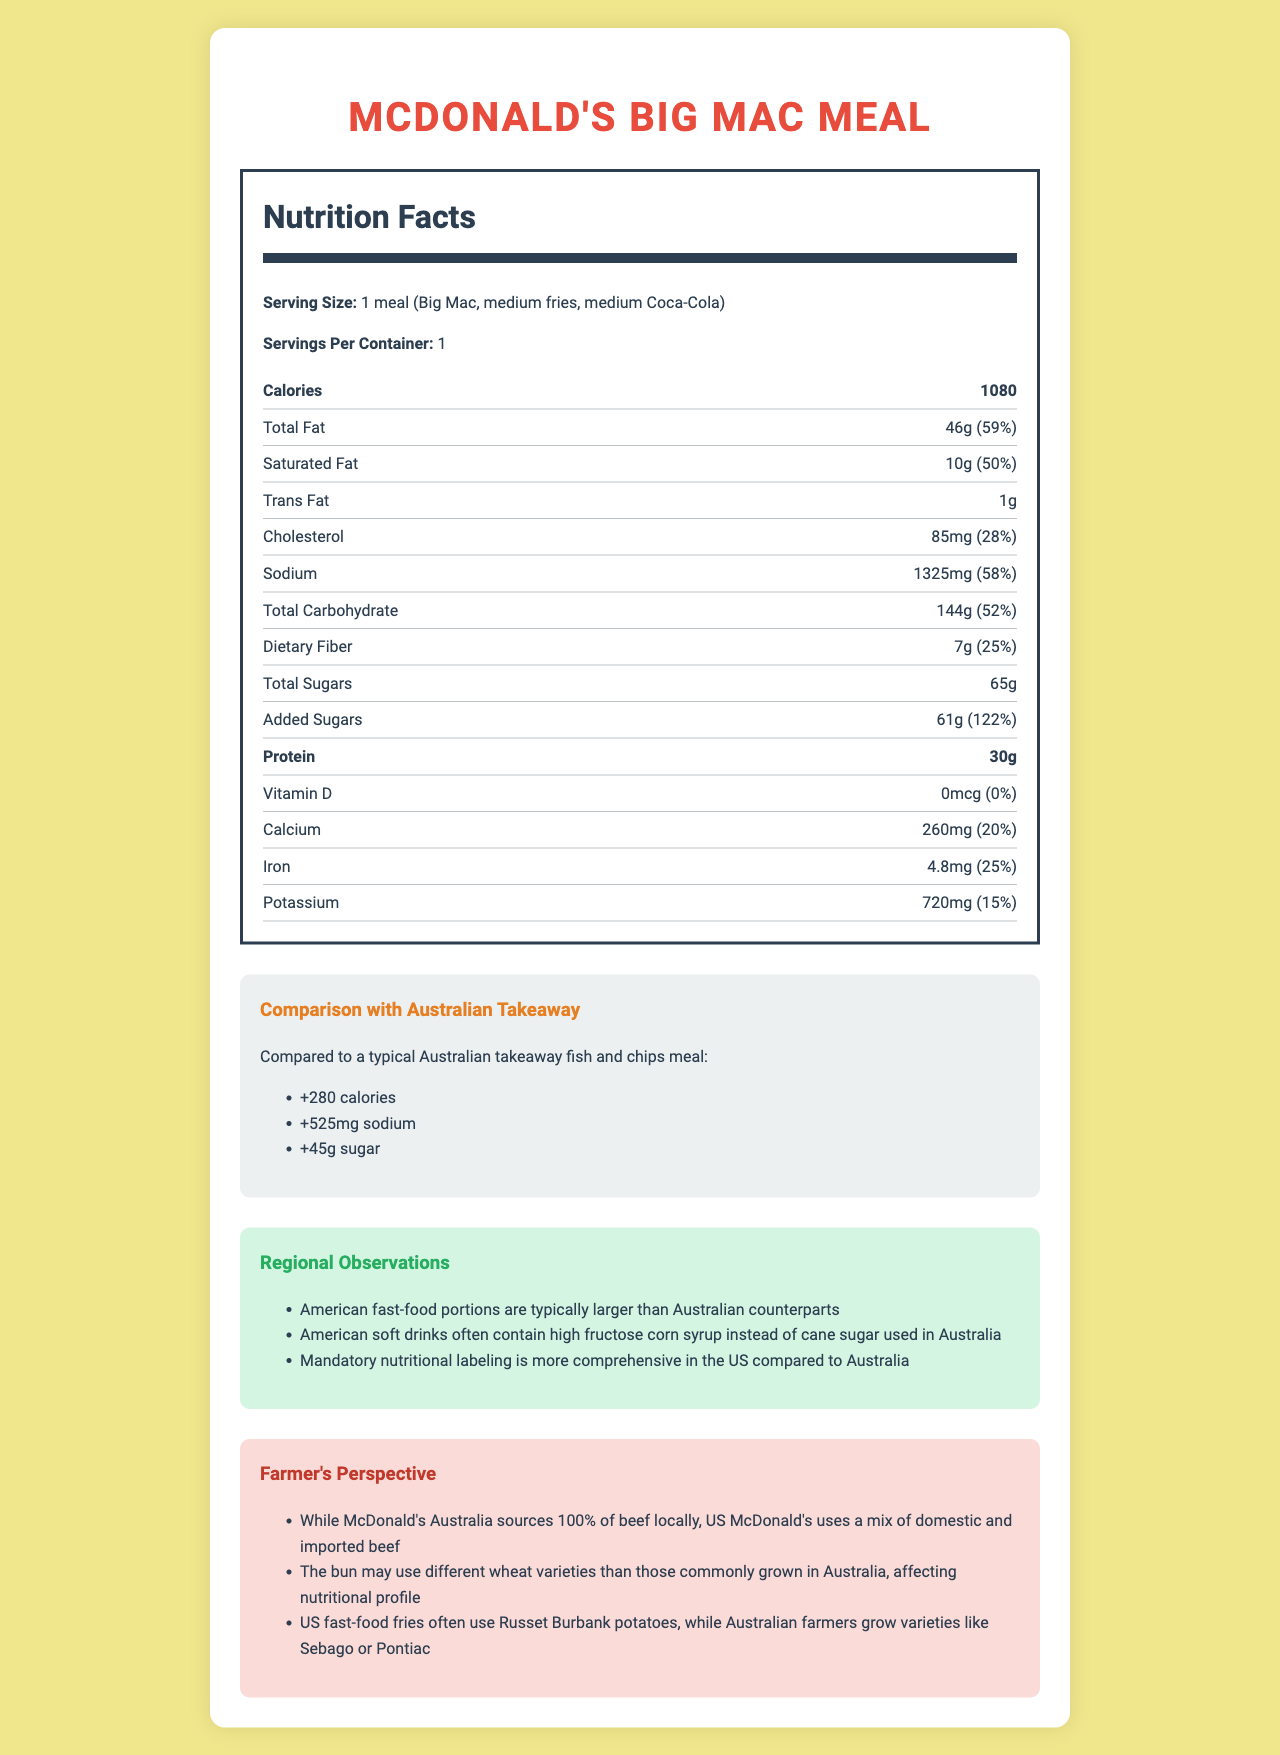what is the serving size of the McDonald's Big Mac Meal? The serving size is clearly stated at the top under the Nutrition Facts heading as "1 meal (Big Mac, medium fries, medium Coca-Cola)".
Answer: 1 meal (Big Mac, medium fries, medium Coca-Cola) how many grams of total fat are in the meal? The total fat amount is listed in the Nutrition Facts section as "46g".
Answer: 46g how much sodium is in the meal? The sodium content is specified in the Nutrition Facts section as "1325mg".
Answer: 1325mg what portion of daily value does the saturated fat contribute? The daily value percentage for saturated fat is shown as "50%".
Answer: 50% how much protein does this meal provide? The amount of protein is listed as "30g" in the Nutrition Facts section.
Answer: 30g which region uses high fructose corn syrup in soft drinks? A. Australia B. United States The regional observation under "soft drink" notes that American soft drinks often contain high fructose corn syrup, unlike Australian drinks which use cane sugar.
Answer: B from where does McDonald's Australia source its beef? A. Domestic B. Imported C. Both domestic and imported The document explicitly states that McDonald’s Australia sources 100% of its beef locally, which implies domestic sources.
Answer: A does the US McDonald's use imported beef in their meals? The farmer’s perspective mentions that US McDonald's uses a mix of domestic and imported beef, confirming the use of imported beef.
Answer: Yes are US fast food portions typically larger than Australian portions? The regional observations section mentions that American fast-food portions are typically larger than their Australian counterparts.
Answer: Yes summarize the main differences between American and Australian fast-food meals as described in this document. The document presents various observations including differences in portion sizes, ingredients like high fructose corn syrup, use of imported and domestic beef, and potato varieties. It also highlights the nutritional labeling practices and the comparative nutritional content of meals.
Answer: American fast-food meals have larger portion sizes, use high fructose corn syrup in soft drinks, and have comprehensive nutritional labeling. They also use both domestic and imported beef, different wheat varieties for buns, and different potato varieties for fries compared to Australian meals. The nutritional profile of a Big Mac meal in the US contains more calories, sodium, and sugars than a typical Australian takeaway meal. what is the difference in caloric content between the McDonald’s Big Mac Meal and a typical Australian takeaway fish and chips meal? The comparison with Australian takeaway fish and chips mentions a "+280 calories" difference.
Answer: +280 calories which potato variety is commonly used for US fast-food fries? The farmer’s perspective indicates that US fast-food fries often use Russet Burbank potatoes.
Answer: Russet Burbank how much added sugar is in the Big Mac Meal? The Nutrition Facts section lists the added sugars amount as "61g".
Answer: 61g what percentage of daily value for iron does the Big Mac Meal provide? The Nutrition Facts section specifies iron's daily value percentage as "25%".
Answer: 25% how is the nutritional labeling different between the US and Australia? A. Less comprehensive in the US B. More comprehensive in Australia C. More comprehensive in the US The regional observations mention that mandatory nutritional labeling is more comprehensive in the US compared to Australia.
Answer: C what is the total amount of sugars in the meal? The total sugar content is listed in the Nutrition Facts section as "65g".
Answer: 65g can the exact variety of wheat used in the buns be determined from the document? The document only mentions that the wheat variety may differ but doesn't specify the exact type used in the buns.
Answer: Cannot be determined 